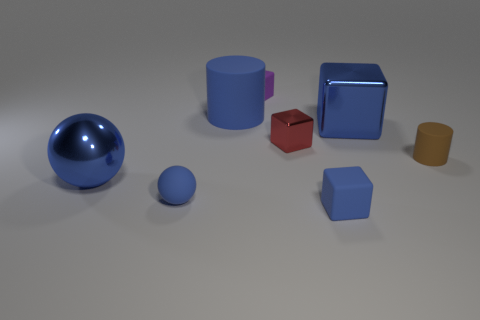Add 2 rubber blocks. How many objects exist? 10 Subtract all cylinders. How many objects are left? 6 Subtract 0 red cylinders. How many objects are left? 8 Subtract all small purple rubber objects. Subtract all tiny metallic things. How many objects are left? 6 Add 3 tiny blue matte objects. How many tiny blue matte objects are left? 5 Add 6 large cubes. How many large cubes exist? 7 